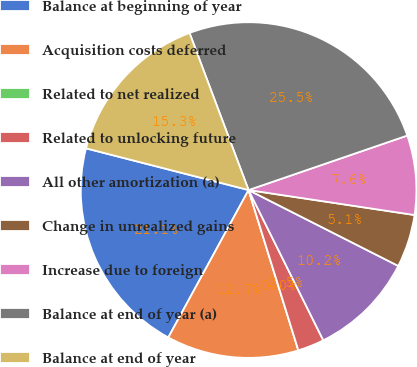<chart> <loc_0><loc_0><loc_500><loc_500><pie_chart><fcel>Balance at beginning of year<fcel>Acquisition costs deferred<fcel>Related to net realized<fcel>Related to unlocking future<fcel>All other amortization (a)<fcel>Change in unrealized gains<fcel>Increase due to foreign<fcel>Balance at end of year (a)<fcel>Balance at end of year<nl><fcel>21.06%<fcel>12.73%<fcel>0.0%<fcel>2.55%<fcel>10.19%<fcel>5.09%<fcel>7.64%<fcel>25.46%<fcel>15.28%<nl></chart> 